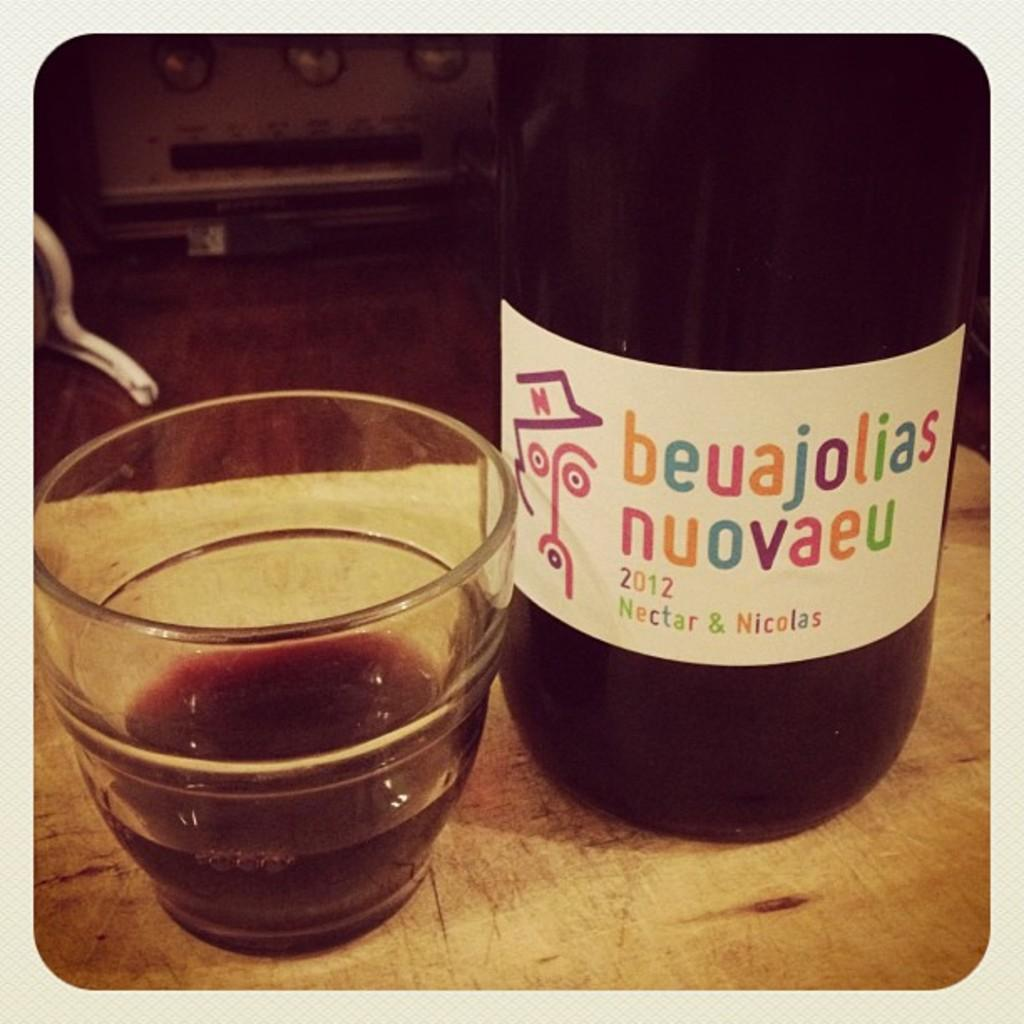<image>
Create a compact narrative representing the image presented. A small glass next to a bottle of beuajolias nuovaeu beverage 